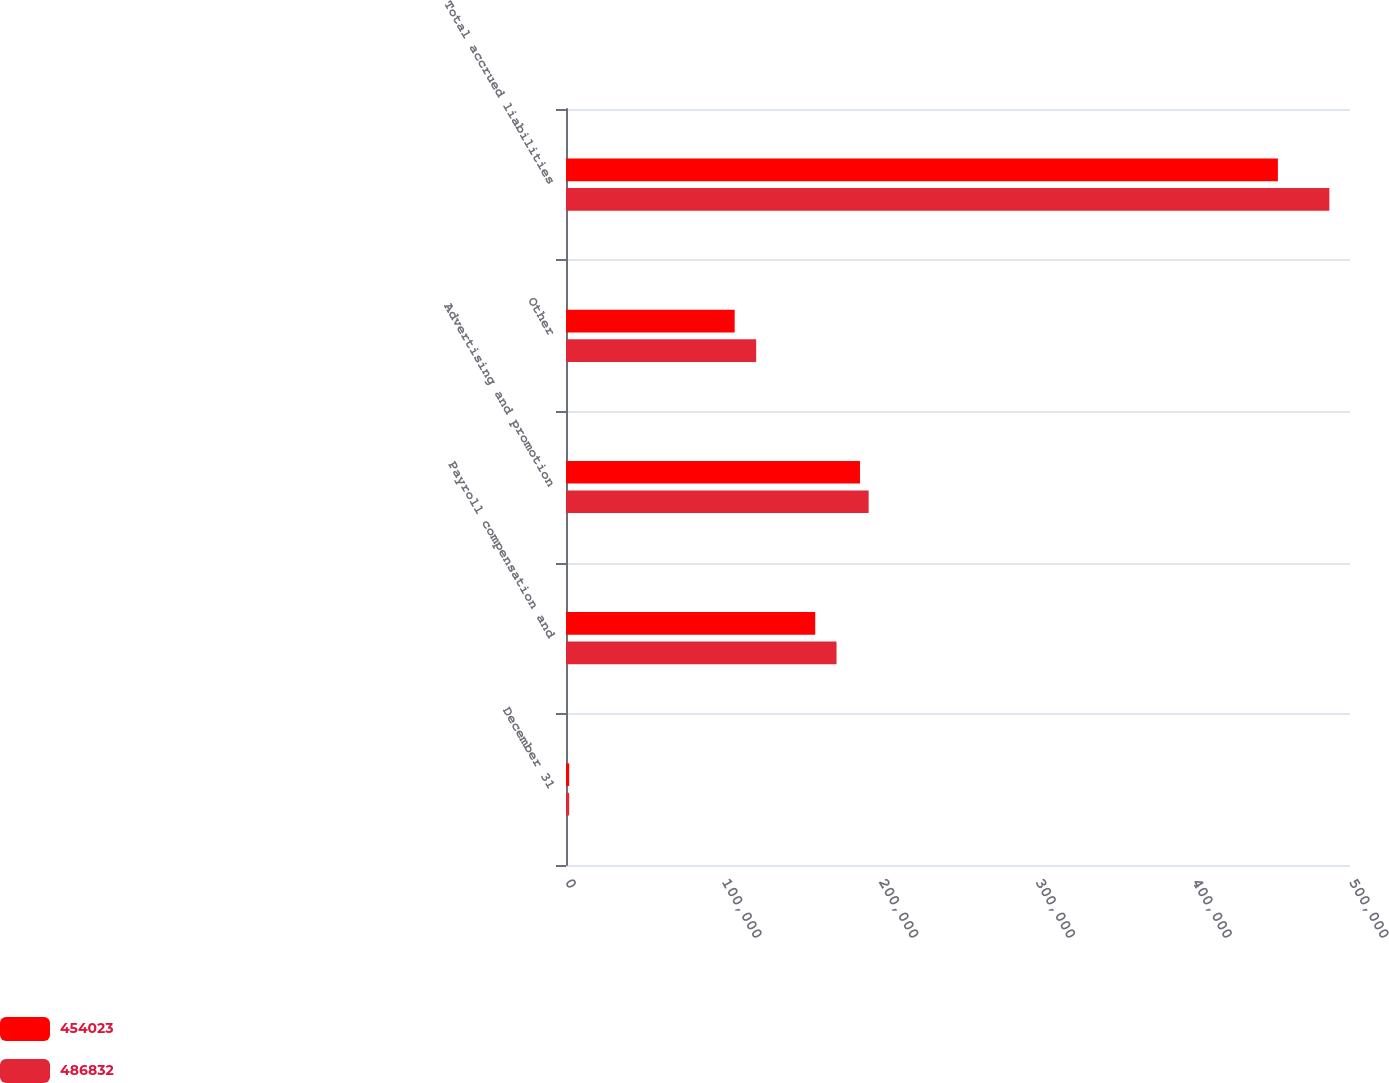Convert chart. <chart><loc_0><loc_0><loc_500><loc_500><stacked_bar_chart><ecel><fcel>December 31<fcel>Payroll compensation and<fcel>Advertising and promotion<fcel>Other<fcel>Total accrued liabilities<nl><fcel>454023<fcel>2006<fcel>158952<fcel>187494<fcel>107577<fcel>454023<nl><fcel>486832<fcel>2005<fcel>172529<fcel>193018<fcel>121285<fcel>486832<nl></chart> 